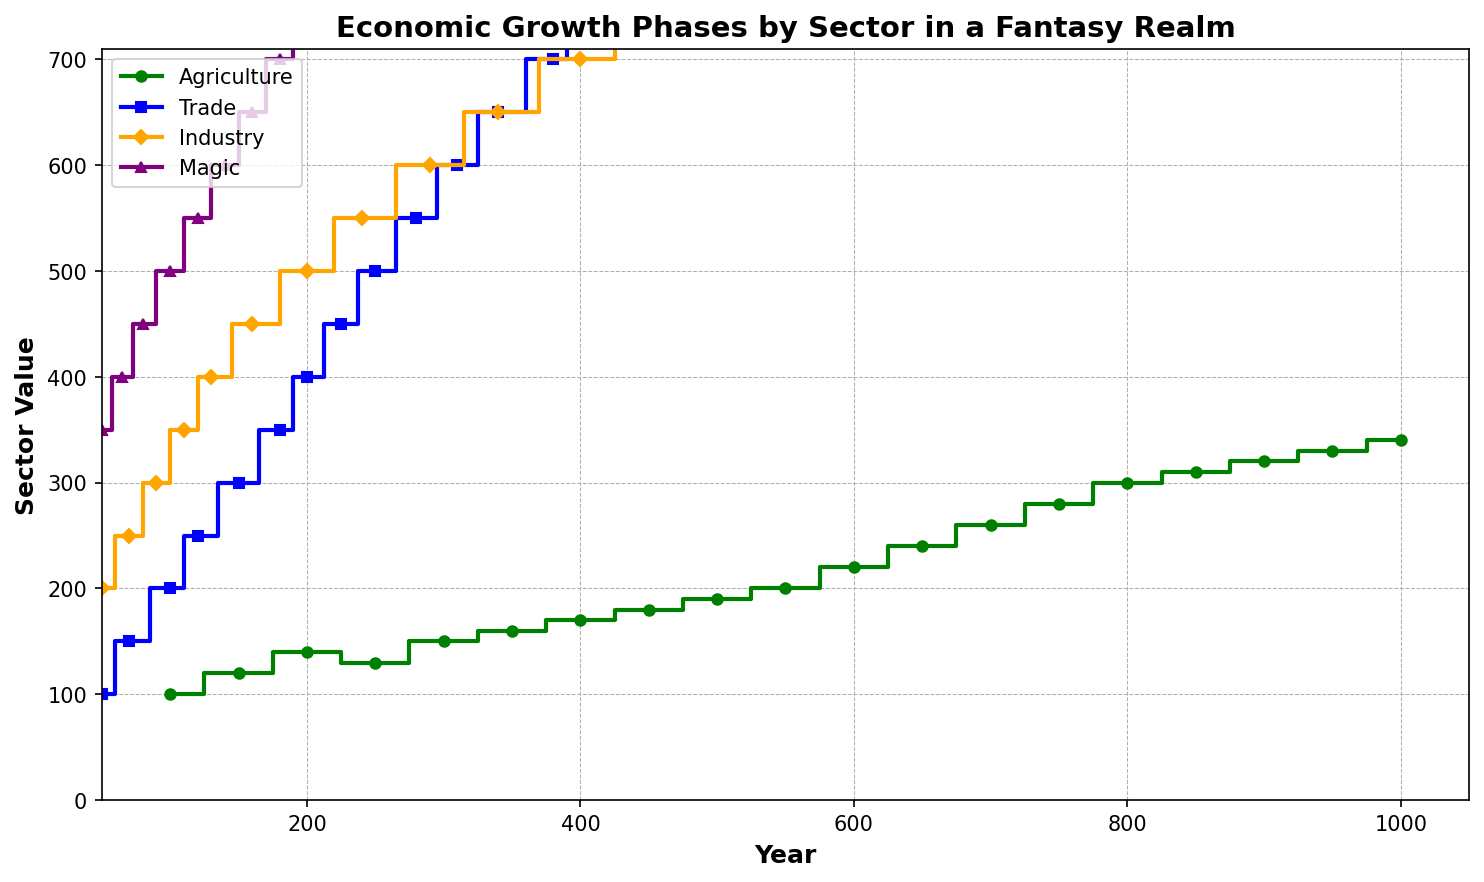Which sector had the highest value in the year 800? Looking at the figure at the specific point for the year 800, find the highest data point among the plotted steps for each sector.
Answer: Magic How much did the Agriculture sector grow between 250 and 300? Identify the Agriculture values for the years 250 and 300 from the plot, then subtract the 250 value from the 300 value to find the growth.
Answer: 20 During which time period did the Trade sector see the largest increase? Examine the plot's step increases for the Trade sector and determine the largest jump between two points on the x-axis.
Answer: 150-200 Is the value of the Magic sector in the year 950 higher than the value of the Agriculture sector in the year 600? Compare the Magic sector's value at 950 with the Agriculture sector's value at 600 by checking their respective points on the plot.
Answer: No What is the average value of the Industry sector from 600 to 1000? Identify the Industry values at the years 600, 650, 700, 750, 800, 850, 900, 950, and 1000. Sum these values and divide by the number of points (9) to get the average.
Answer: 410 Which sector showed the least growth between the year 100 and 150? Find the value difference for each sector between 100 and 150, and determine which is the smallest.
Answer: Industry By how much did the value of Magic increase from 450 to 500? Subtract the Magic sector's value at 450 from its value at 500 to find the increase.
Answer: 20 Compare the total growth of the Agriculture and Industry sectors from 100 to 700. Which sector grew more? Calculate the growth for both sectors by finding the differences in their values between 100 and 700, then compare the results.
Answer: Industry How much higher is the value of Trade compared to Agriculture at the year 650? Subtract the Agriculture value at 650 from the Trade value at 650.
Answer: 100 What can be said about the relative growth trends of Industry versus Magic throughout the timeline? Look at the step plot for both sectors across the timeline to see if there are periods where Industry consistently grows faster or slower compared to Magic.
Answer: Industry grows faster 